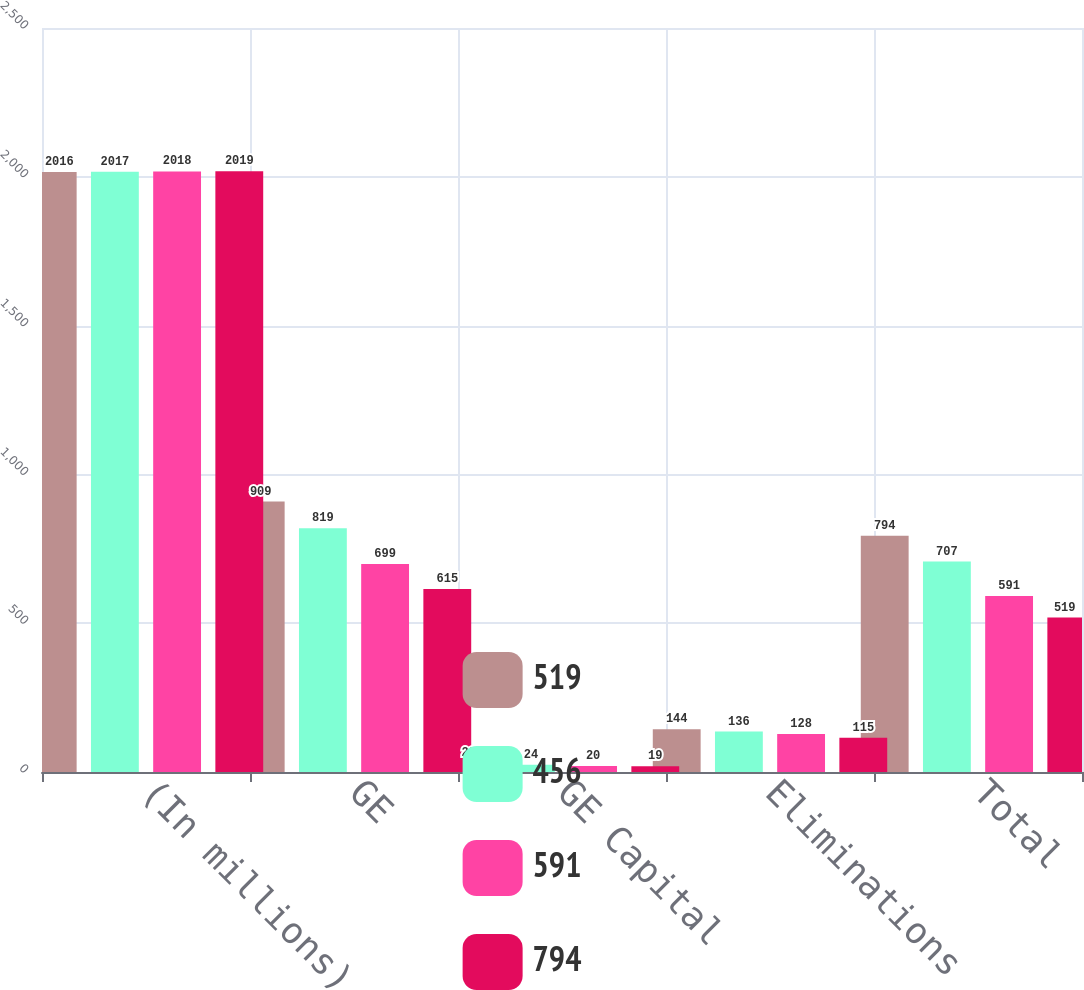<chart> <loc_0><loc_0><loc_500><loc_500><stacked_bar_chart><ecel><fcel>(In millions)<fcel>GE<fcel>GE Capital<fcel>Eliminations<fcel>Total<nl><fcel>519<fcel>2016<fcel>909<fcel>29<fcel>144<fcel>794<nl><fcel>456<fcel>2017<fcel>819<fcel>24<fcel>136<fcel>707<nl><fcel>591<fcel>2018<fcel>699<fcel>20<fcel>128<fcel>591<nl><fcel>794<fcel>2019<fcel>615<fcel>19<fcel>115<fcel>519<nl></chart> 